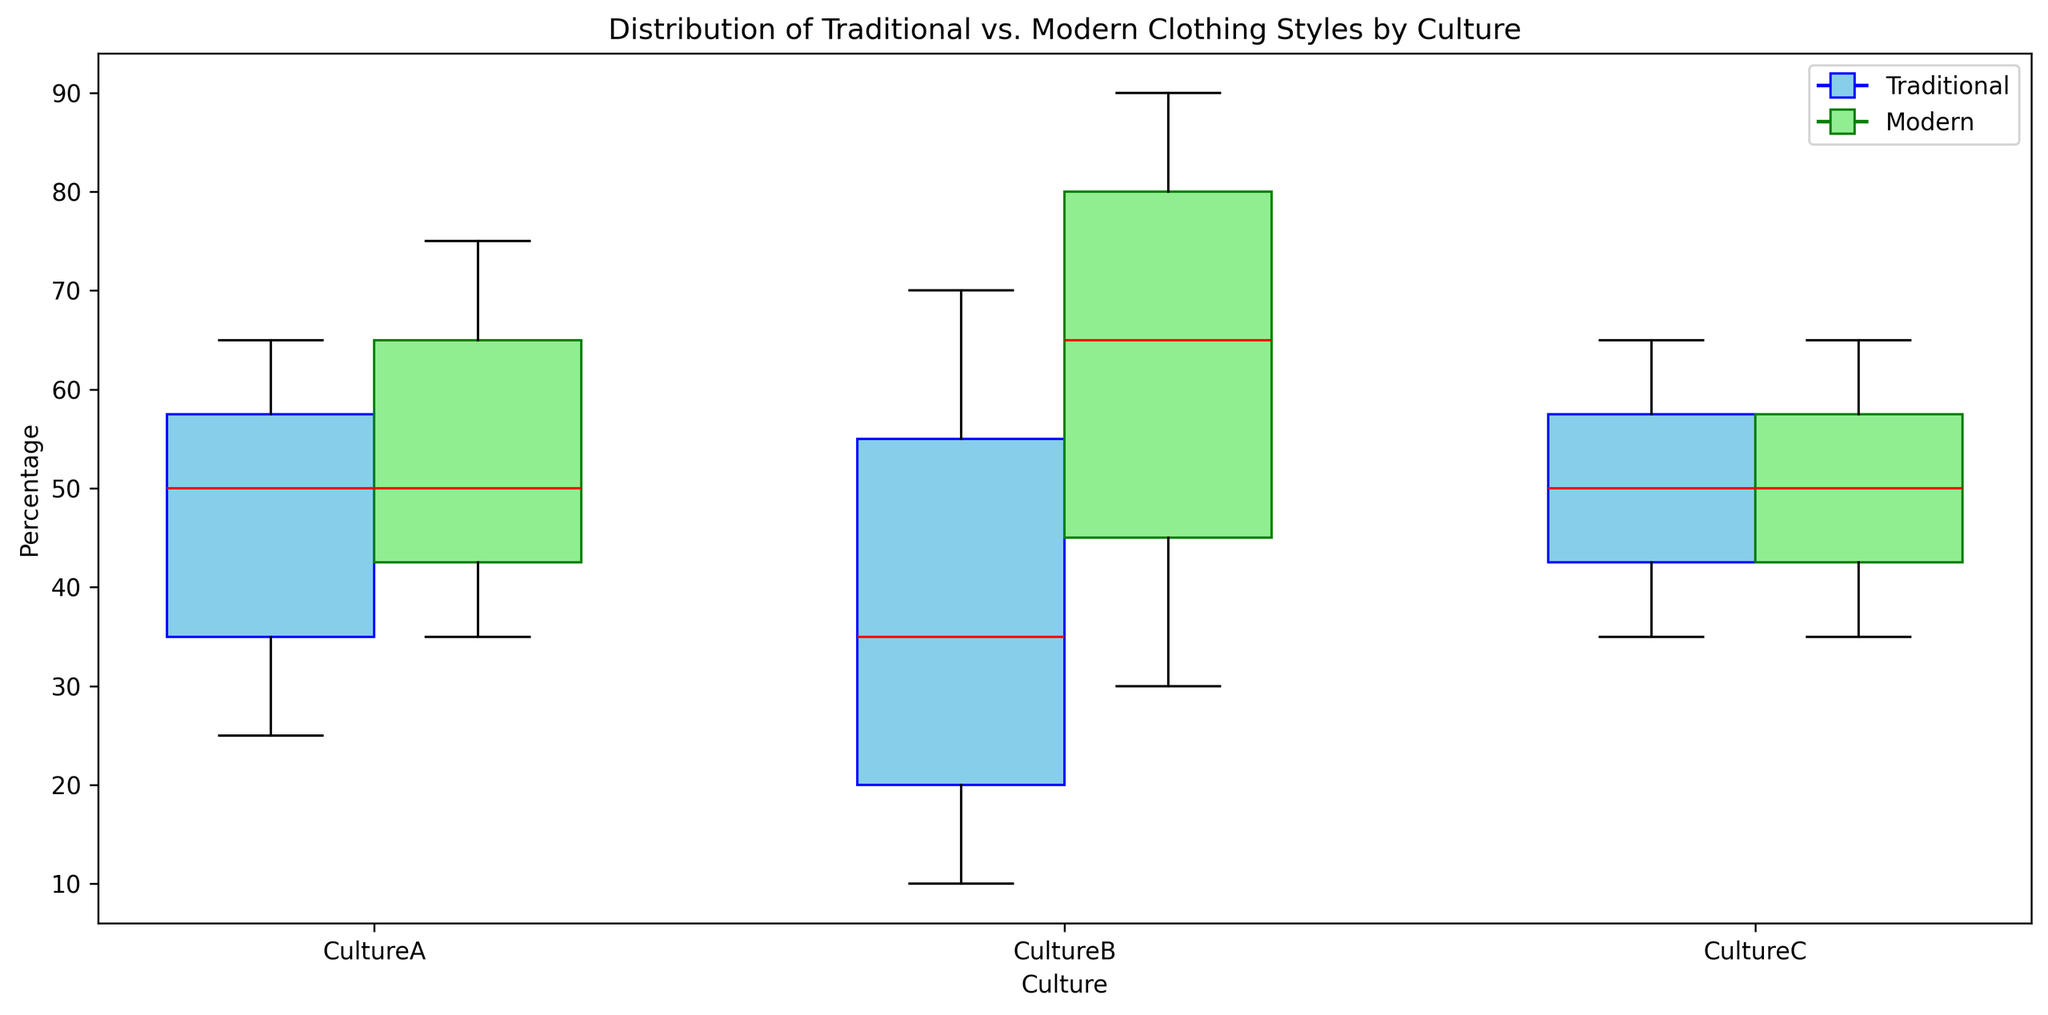How do the median percentages of traditional clothing in CultureA and CultureC compare? To determine this, observe the median lines (drawn in red) for the box plots of traditional clothing in CultureA and CultureC. In CultureA, the median percentage of traditional clothing is around 50%, while in CultureC, it is slightly below 50%. Therefore, the median for CultureA is higher than that for CultureC.
Answer: CultureA's median is higher Which culture has the largest range for the percentage of traditional clothing across age groups? The range is the difference between the maximum and minimum values. Look at the box plots' whiskers for the traditional data. For CultureB, the traditional clothing percentage ranges from 10% to 70%, a span of 60 percentage points. This is the largest range compared to CultureA and CultureC.
Answer: CultureB What is the color used to represent modern clothing in the figure? The modern clothing box plots are filled with light green, as indicated in the legend.
Answer: Light green Which culture shows a trend where traditional clothing increases with age? Examine the traditional clothing box plots for each culture. In CultureA and CultureB, there is a clear pattern where the median percentage increases as the age group rises. CultureC does not follow this trend uniformly.
Answer: CultureA and CultureB What is the median percentage of modern clothing for CultureB? Observe the red median line in the box plot for modern clothing in CultureB. The median value is around 75%.
Answer: 75% How many cultures show a balanced (50%) median percentage of traditional and modern clothing in at least one age group? Check the median lines for both traditional and modern clothing for each culture. CultureA and CultureB each have age groups with boxes showing a median at 50%. CultureC does not have any 50% medians for either clothing type. Thus, there are 2 such cultures.
Answer: 2 Which culture has the most significant difference in the median percentages of modern clothing between any two age groups? Look for the largest vertical difference between red median lines of the modern clothing box plots within each culture. For CultureB, the modern clothing median changes significantly from younger age groups (e.g., 90% for 0-10) to older age groups (e.g., 30% for 61+), indicating the largest difference.
Answer: CultureB Is there any culture where the median percentage of modern clothing is higher than traditional clothing in all age groups? For each culture, compare the red median lines for modern clothing to those of traditional clothing across all age groups. In CultureC, the median percentages for traditional and modern clothing are not consistently higher for either type across all age groups. CultureB shows modern clothing having higher median percentages across all age groups. CultureA has some age groups where traditional clothing is higher. Therefore, CultureB is the answer.
Answer: CultureB 